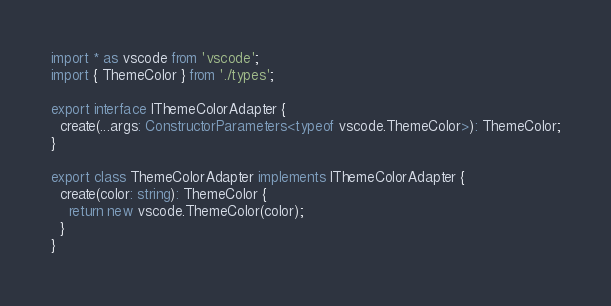Convert code to text. <code><loc_0><loc_0><loc_500><loc_500><_TypeScript_>import * as vscode from 'vscode';
import { ThemeColor } from './types';

export interface IThemeColorAdapter {
  create(...args: ConstructorParameters<typeof vscode.ThemeColor>): ThemeColor;
}

export class ThemeColorAdapter implements IThemeColorAdapter {
  create(color: string): ThemeColor {
    return new vscode.ThemeColor(color);
  }
}
</code> 